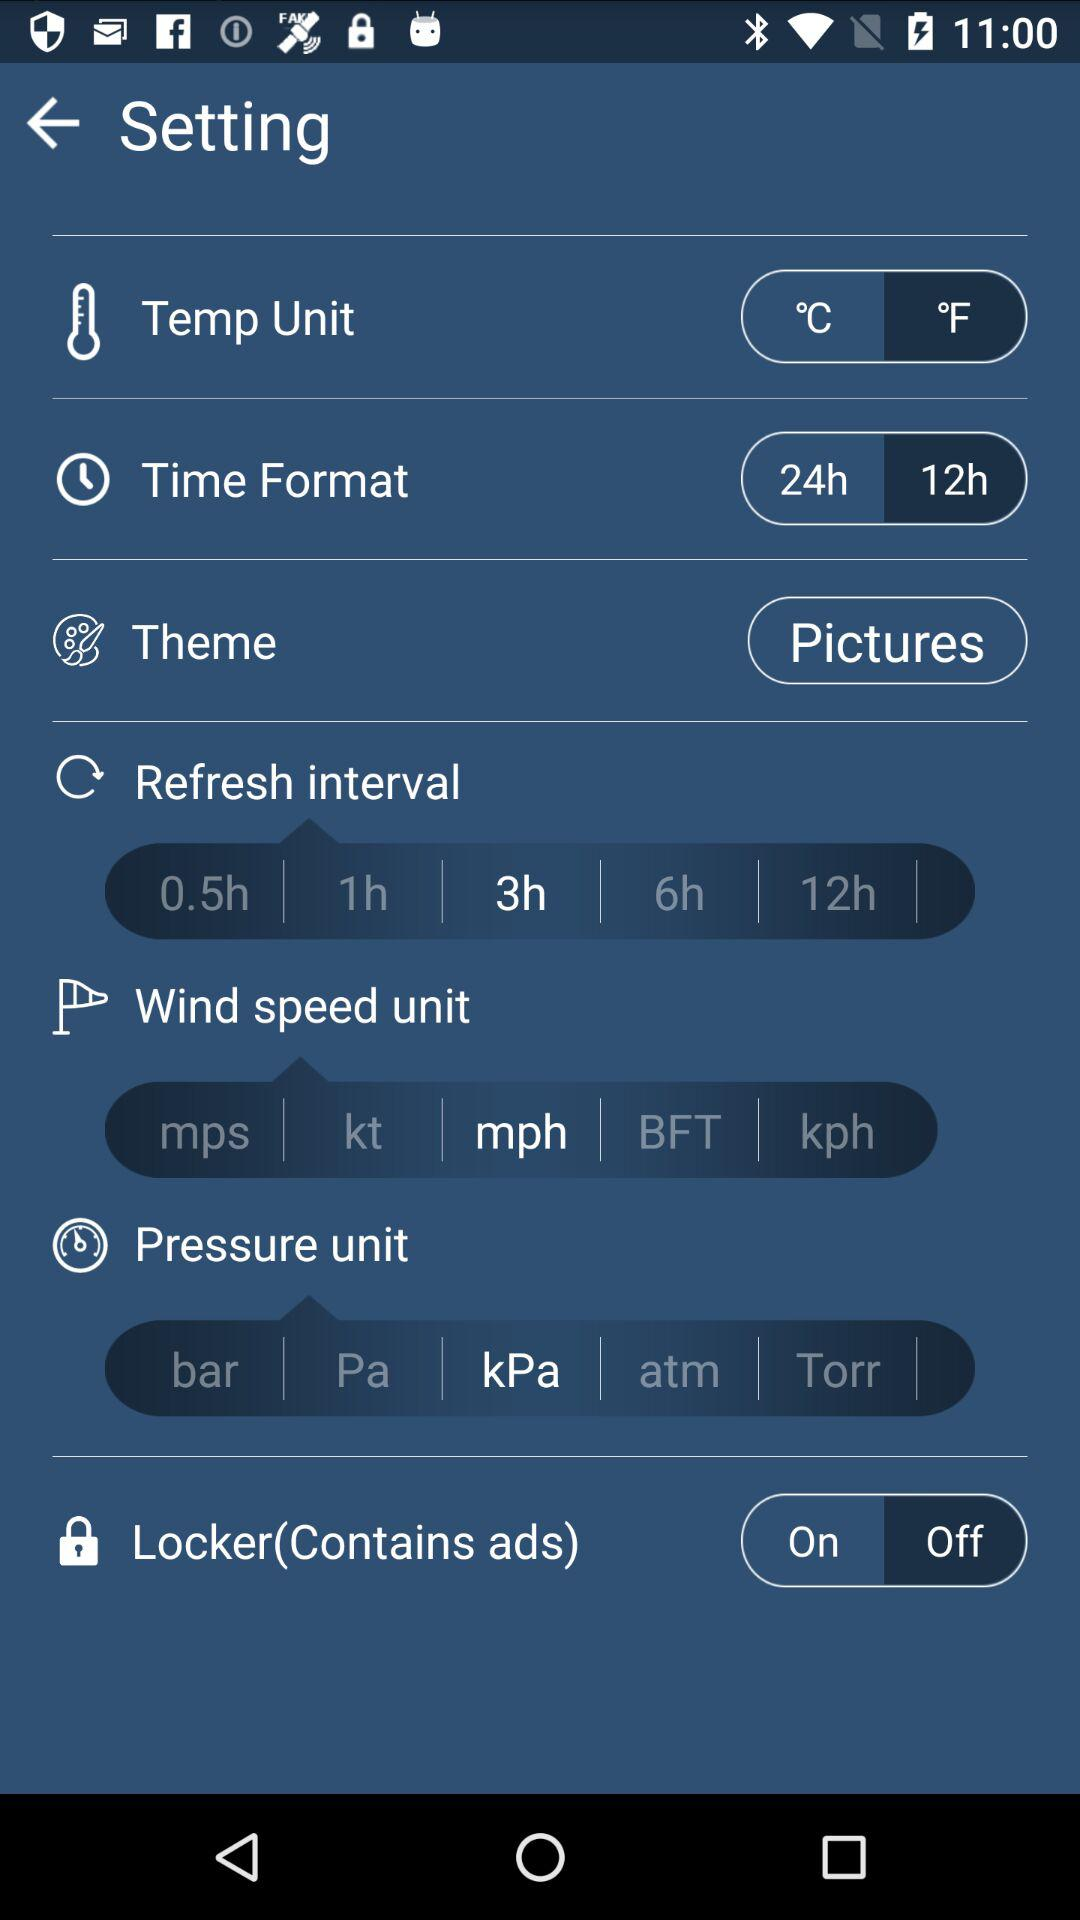What is the status of "Locker"? The status is "off". 